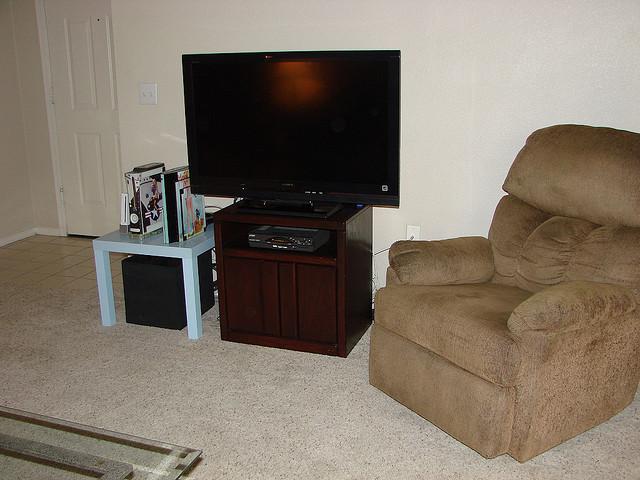Is this item an appropriate gift for a toddler?
Short answer required. No. What is this room?
Be succinct. Living room. What color is the chair?
Short answer required. Brown. Is the tv on?
Short answer required. No. What color is the furniture?
Keep it brief. Brown. 